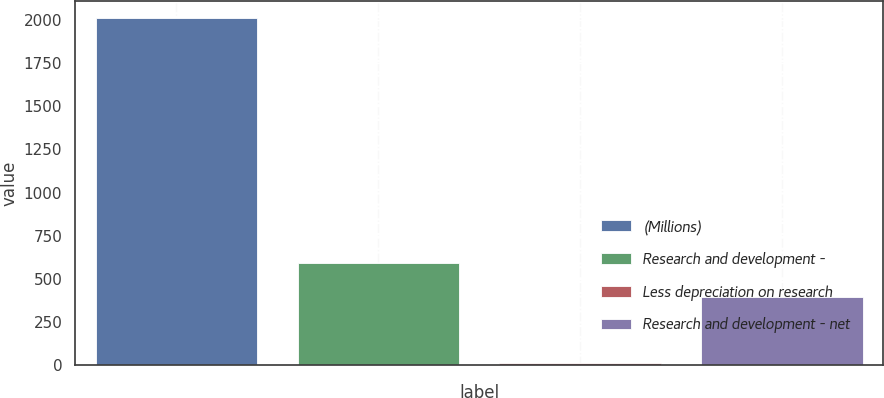Convert chart. <chart><loc_0><loc_0><loc_500><loc_500><bar_chart><fcel>(Millions)<fcel>Research and development -<fcel>Less depreciation on research<fcel>Research and development - net<nl><fcel>2010<fcel>593.6<fcel>14<fcel>394<nl></chart> 